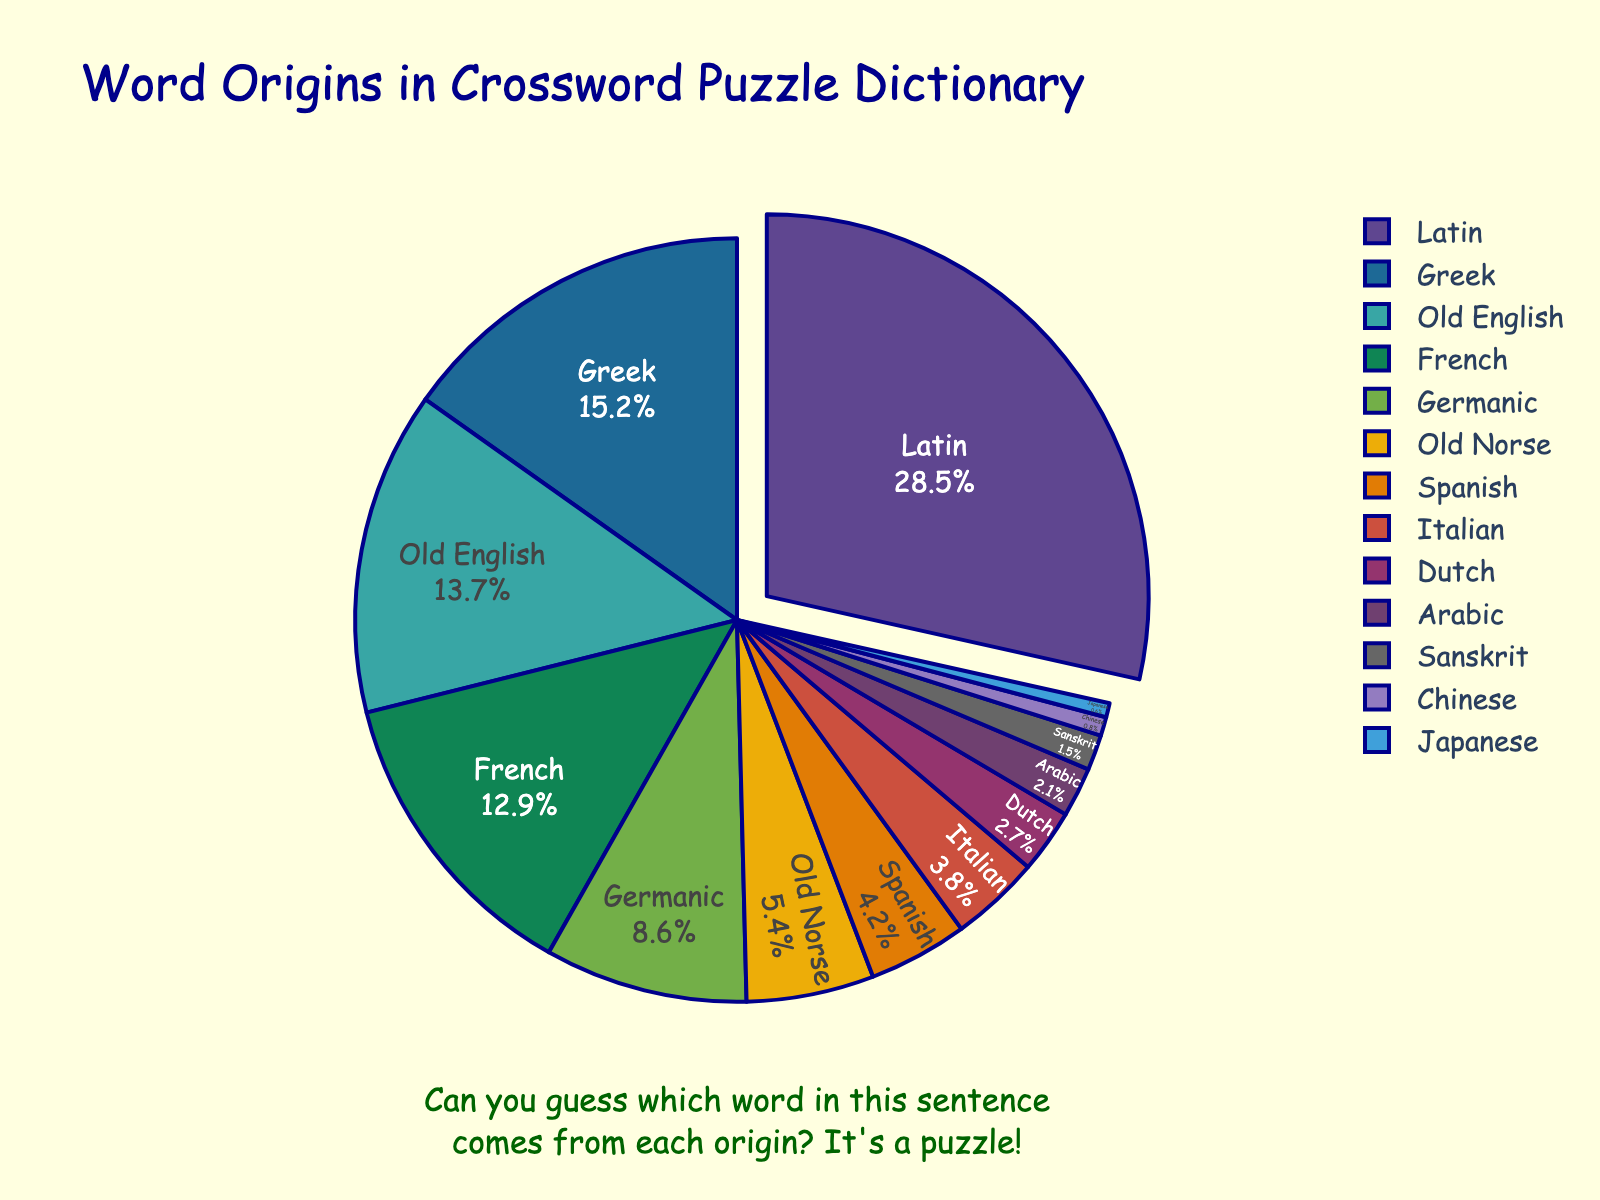What percentage of words come from Latin and Greek combined? First, identify the percentages for Latin (28.5%) and Greek (15.2%). Then sum them up: 28.5 + 15.2 = 43.7.
Answer: 43.7% Which origin contributes a higher percentage: French or Germanic? Locate the percentages for French (12.9%) and Germanic (8.6%) and compare them. Since 12.9% > 8.6%, French contributes more.
Answer: French Among Latin, Greek, and Old English, which has the lowest percentage? Check the percentages for Latin (28.5%), Greek (15.2%), and Old English (13.7%). Identify the smallest value, which is 13.7% for Old English.
Answer: Old English In terms of percentage, how much more do words from Latin contribute compared to words from Spanish? Identify the percentages for Latin (28.5%) and Spanish (4.2%). Calculate the difference: 28.5 - 4.2 = 24.3.
Answer: 24.3% What percentage of words come from non-Indo-European languages (Arabic, Chinese, Japanese)? Add the percentages for Arabic (2.1%), Chinese (0.8%), and Japanese (0.6%): 2.1 + 0.8 + 0.6 = 3.5.
Answer: 3.5% Which two origins have the closest percentages? Compare the percentages: Spanish (4.2%) and Italian (3.8%) are closest with a difference of 4.2 - 3.8 = 0.4.
Answer: Spanish and Italian What is the total percentage of words from Old Norse and Dutch combined? Find the percentages for Old Norse (5.4%) and Dutch (2.7%) and sum them up: 5.4 + 2.7 = 8.1.
Answer: 8.1% Is the percentage of words from Germanic greater than twice the percentage of words from Sanskrit? Find the percentages for Germanic (8.6%) and Sanskrit (1.5%). Calculate twice the percentage of Sanskrit: 1.5 * 2 = 3. Compare 8.6 with 3; since 8.6 > 3, the statement is true.
Answer: Yes Which origin contributes the smallest percentage? Identify the origin with the smallest percentage, which is Japanese at 0.6%.
Answer: Japanese 